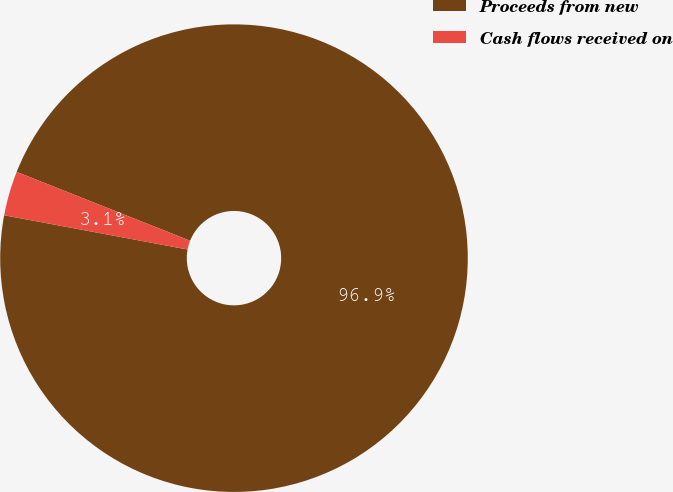Convert chart. <chart><loc_0><loc_0><loc_500><loc_500><pie_chart><fcel>Proceeds from new<fcel>Cash flows received on<nl><fcel>96.92%<fcel>3.08%<nl></chart> 